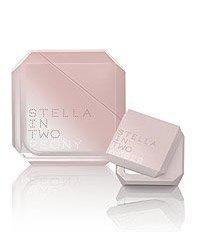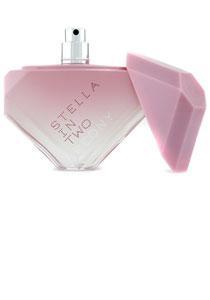The first image is the image on the left, the second image is the image on the right. Analyze the images presented: Is the assertion "One image contains a bottle shaped like an inverted triangle with its triangular cap alongside it, and the other image includes a bevel-edged square pink object." valid? Answer yes or no. Yes. The first image is the image on the left, the second image is the image on the right. Given the left and right images, does the statement "A perfume bottle is standing on one corner with the lid off." hold true? Answer yes or no. Yes. 